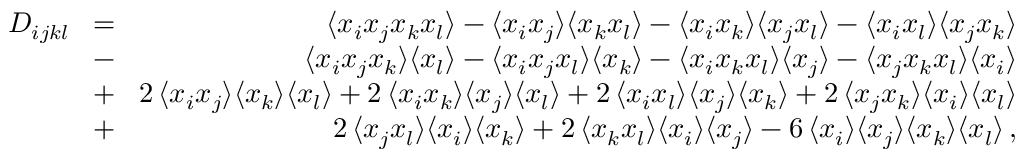Convert formula to latex. <formula><loc_0><loc_0><loc_500><loc_500>\begin{array} { r l r } { D _ { i j k l } } & { \, = \, } & { \langle x _ { i } x _ { j } x _ { k } x _ { l } \rangle - \langle x _ { i } x _ { j } \rangle \langle x _ { k } x _ { l } \rangle - \langle x _ { i } x _ { k } \rangle \langle x _ { j } x _ { l } \rangle - \langle x _ { i } x _ { l } \rangle \langle x _ { j } x _ { k } \rangle } \\ & { \, - \, } & { \langle x _ { i } x _ { j } x _ { k } \rangle \langle x _ { l } \rangle - \langle x _ { i } x _ { j } x _ { l } \rangle \langle x _ { k } \rangle - \langle x _ { i } x _ { k } x _ { l } \rangle \langle x _ { j } \rangle - \langle x _ { j } x _ { k } x _ { l } \rangle \langle x _ { i } \rangle } \\ & { \, + \, } & { 2 \, \langle x _ { i } x _ { j } \rangle \langle x _ { k } \rangle \langle x _ { l } \rangle + 2 \, \langle x _ { i } x _ { k } \rangle \langle x _ { j } \rangle \langle x _ { l } \rangle + 2 \, \langle x _ { i } x _ { l } \rangle \langle x _ { j } \rangle \langle x _ { k } \rangle + 2 \, \langle x _ { j } x _ { k } \rangle \langle x _ { i } \rangle \langle x _ { l } \rangle } \\ & { \, + \, } & { 2 \, \langle x _ { j } x _ { l } \rangle \langle x _ { i } \rangle \langle x _ { k } \rangle + 2 \, \langle x _ { k } x _ { l } \rangle \langle x _ { i } \rangle \langle x _ { j } \rangle - 6 \, \langle x _ { i } \rangle \langle x _ { j } \rangle \langle x _ { k } \rangle \langle x _ { l } \rangle \, , } \end{array}</formula> 